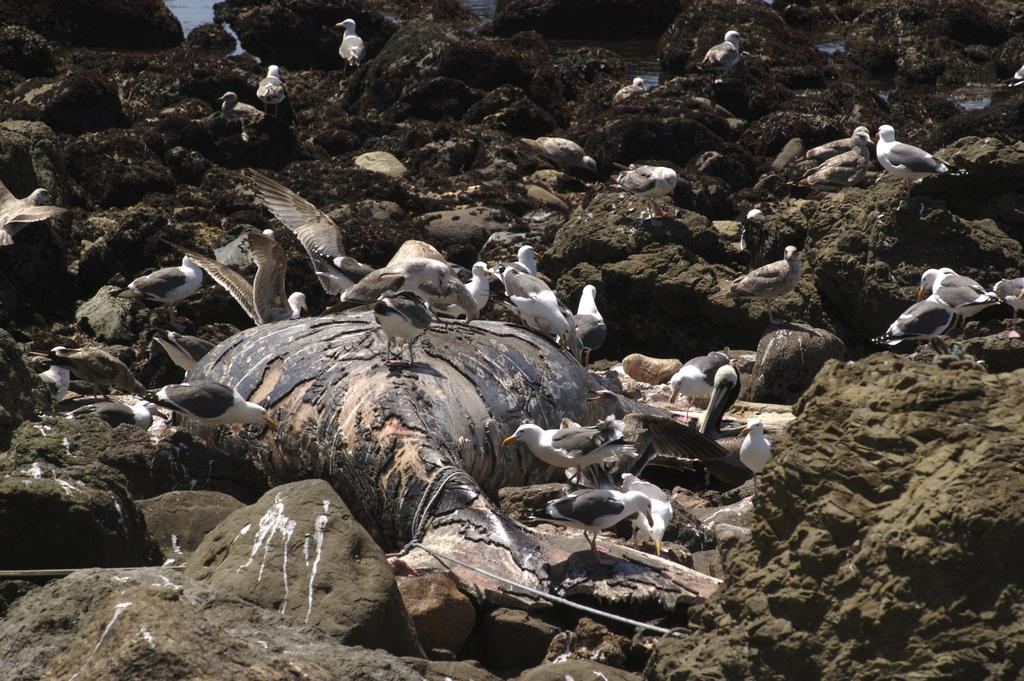What is the main subject in the center of the image? There is a dead animal in the center of the image. What other living creatures can be seen in the image? There are birds in the image. What type of inanimate objects are present in the image? There are rocks in the image. What type of crook can be seen in the image? There is no crook present in the image. How many mittens are visible in the image? There are no mittens present in the image. 